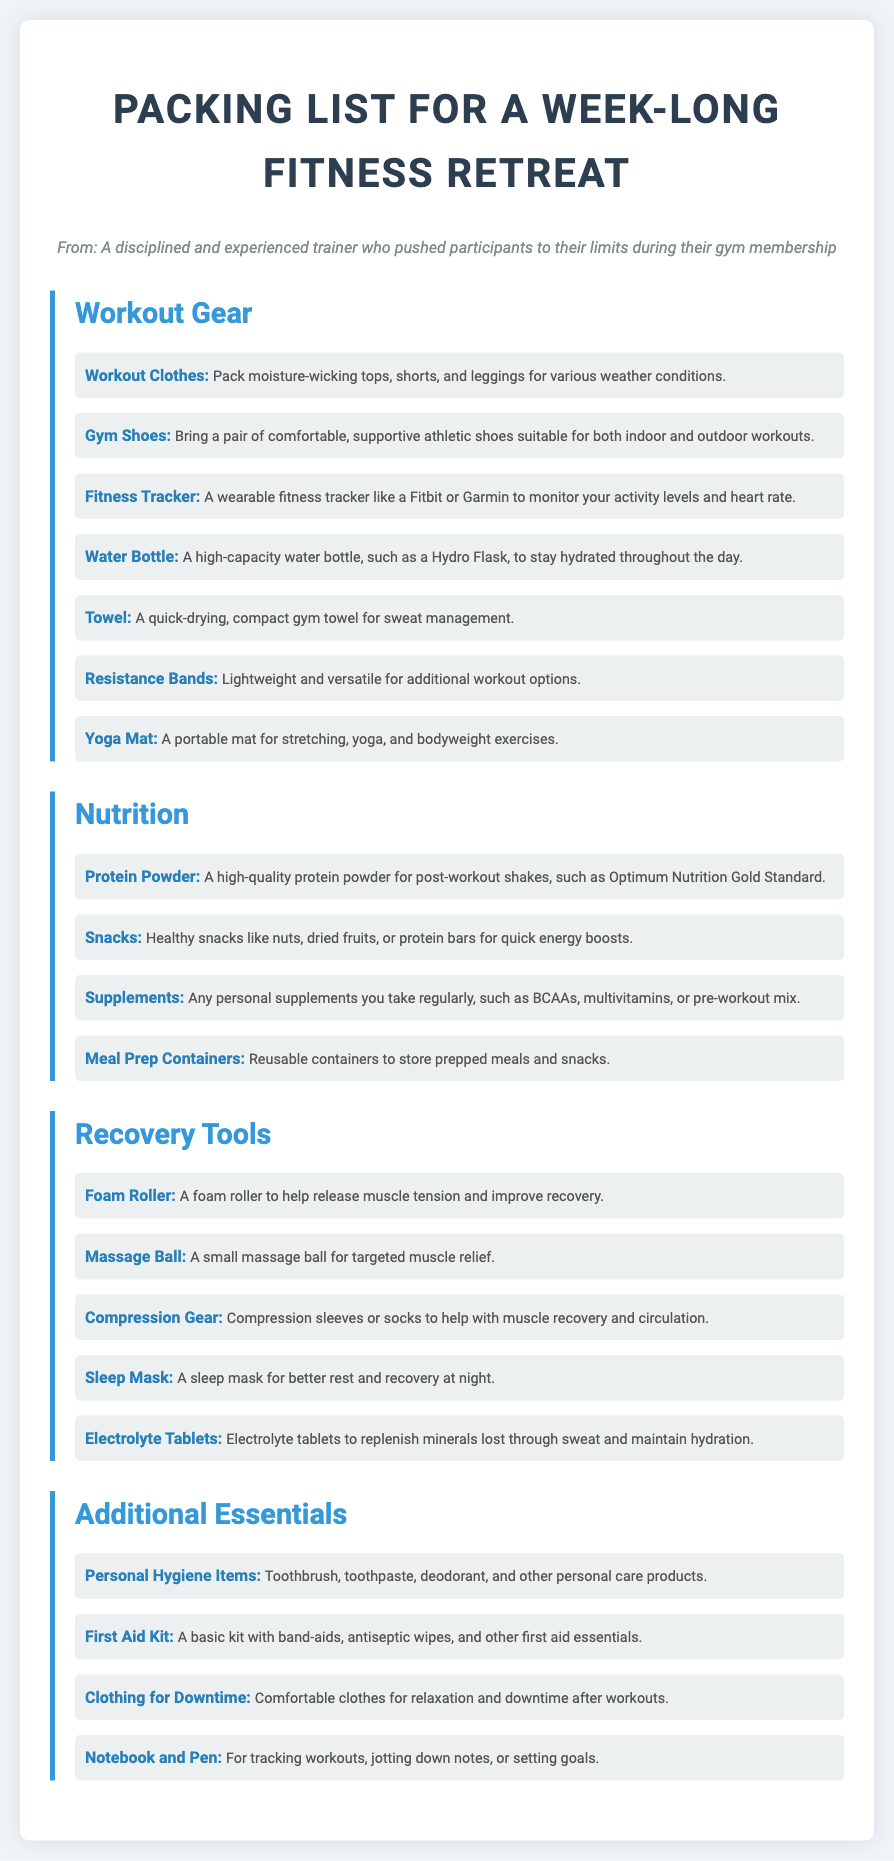what is one type of workout gear suggested? The document lists various types of workout gear, one of which includes workout clothes that are moisture-wicking.
Answer: workout clothes how many nutrition items are listed? The document contains four distinct nutrition items under the Nutrition section.
Answer: four what is a recommended hydration tool? A high-capacity water bottle is mentioned as a hydration tool to stay hydrated throughout the day.
Answer: water bottle what is included in the recovery tools section? In the Recovery Tools section, a foam roller is listed as a recovery tool to help release muscle tension.
Answer: foam roller what personal item is suggested for better sleep? The document recommends bringing a sleep mask to help improve rest and recovery at night.
Answer: sleep mask which item can be used for muscle relief? A massage ball is mentioned for targeted muscle relief under Recovery Tools.
Answer: massage ball how many items are listed under workout gear? There are seven items listed under the Workout Gear section.
Answer: seven what is a recommended protein supplement? The document suggests Optimum Nutrition Gold Standard as a high-quality protein powder.
Answer: Optimum Nutrition Gold Standard what type of clothing is mentioned for downtime? Comfortable clothes are suggested for relaxation and downtime after workouts.
Answer: comfortable clothes 